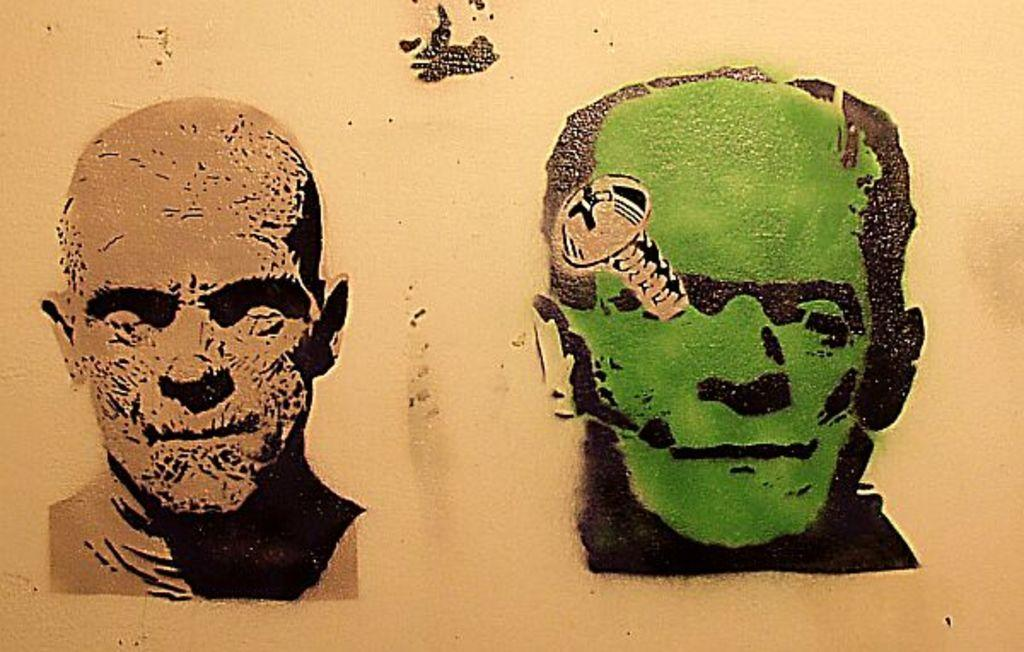What is depicted on the wall in the image? There is a drawing of faces on the wall in the image. Can you describe any specific details about the drawing? Yes, there is a screw on the face on the right side of the image. How many steps are there in the image? There are no steps present in the image. 